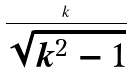Convert formula to latex. <formula><loc_0><loc_0><loc_500><loc_500>\frac { k } { \sqrt { k ^ { 2 } - 1 } }</formula> 